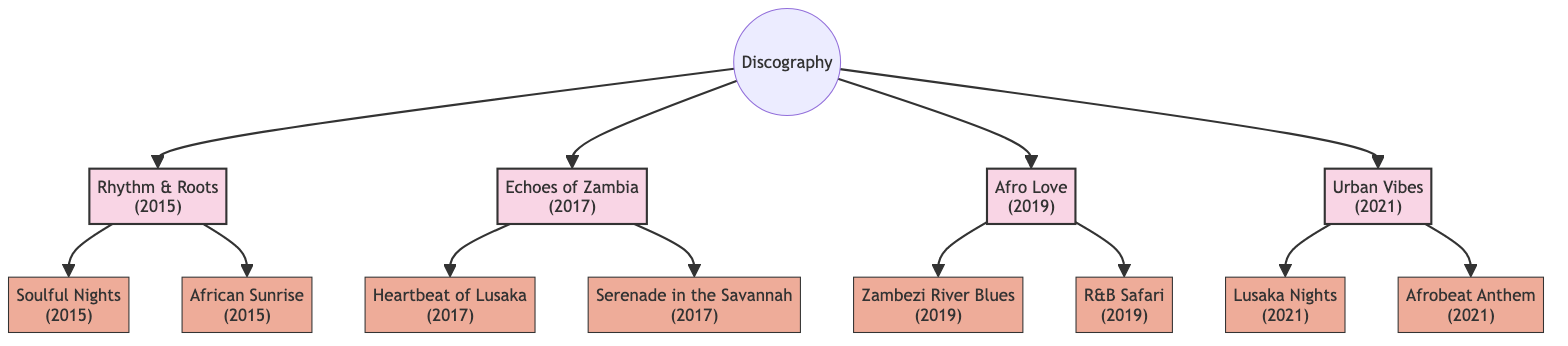What is the name of the first album? The diagram shows the album "Rhythm & Roots" as the first one listed under the "Discography" node.
Answer: Rhythm & Roots How many albums are listed in the discography? There are four albums shown in the diagram, each connected to the central "Discography" node.
Answer: 4 Which album was released in 2019? The diagram indicates that "Afro Love" is the album associated with the year 2019.
Answer: Afro Love What are the major singles from "Echoes of Zambia"? The singles connected to "Echoes of Zambia" are "Heartbeat of Lusaka" and "Serenade in the Savannah," as shown by the lines connecting them in the diagram.
Answer: Heartbeat of Lusaka, Serenade in the Savannah Which album features the single "Afrobeat Anthem"? The diagram shows that "Afrobeat Anthem" is a major single connected to the album "Urban Vibes," indicating it belongs to that album.
Answer: Urban Vibes How many major singles were released in 2015? The diagram lists two singles, "Soulful Nights" and "African Sunrise," under the album "Rhythm & Roots" which was released in 2015.
Answer: 2 Which single was released last out of all major singles? The last single mentioned in the diagram under the latest album "Urban Vibes" is "Afrobeat Anthem," as it is positioned last in the flow of the tree.
Answer: Afrobeat Anthem What is the relationship between "Afro Love" and "Zambezi River Blues"? "Zambezi River Blues" is a major single associated with the album "Afro Love," as indicated by the direct connection in the diagram.
Answer: Major single Which album comes after "Echoes of Zambia"? The diagram indicates "Afro Love" follows "Echoes of Zambia" in the sequence of albums listed.
Answer: Afro Love 